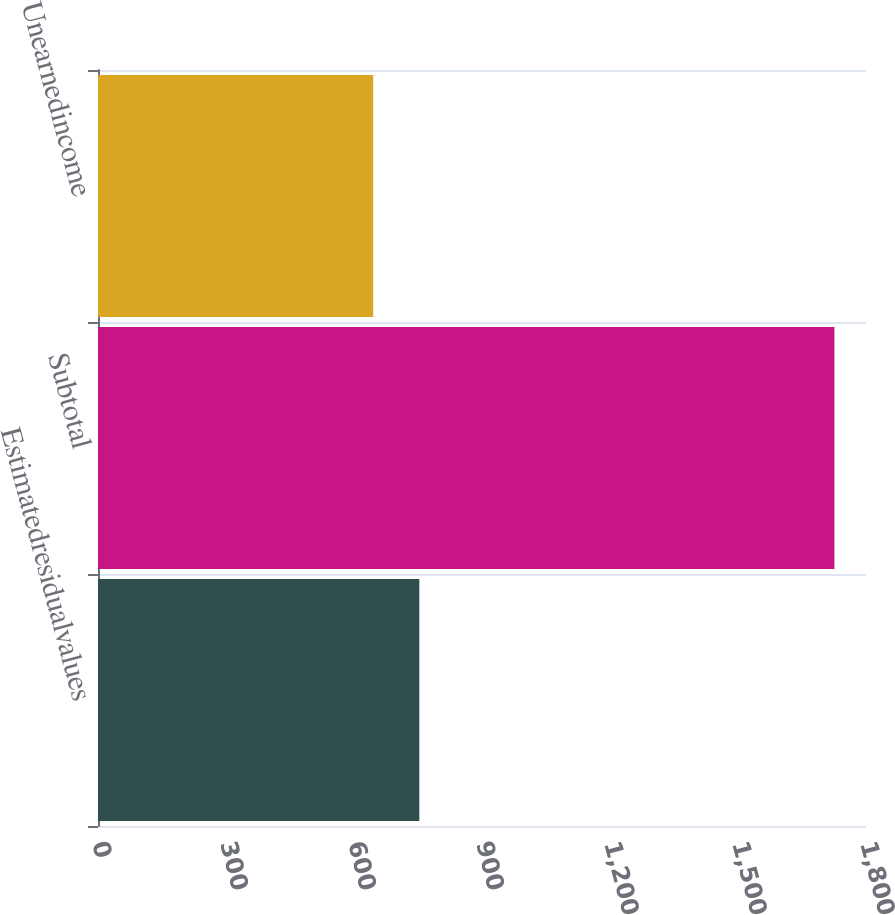Convert chart. <chart><loc_0><loc_0><loc_500><loc_500><bar_chart><fcel>Estimatedresidualvalues<fcel>Subtotal<fcel>Unearnedincome<nl><fcel>753.1<fcel>1726<fcel>645<nl></chart> 